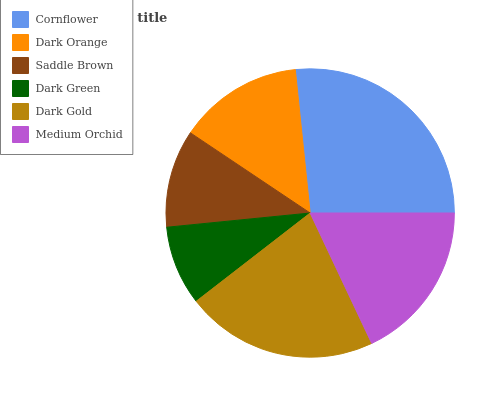Is Dark Green the minimum?
Answer yes or no. Yes. Is Cornflower the maximum?
Answer yes or no. Yes. Is Dark Orange the minimum?
Answer yes or no. No. Is Dark Orange the maximum?
Answer yes or no. No. Is Cornflower greater than Dark Orange?
Answer yes or no. Yes. Is Dark Orange less than Cornflower?
Answer yes or no. Yes. Is Dark Orange greater than Cornflower?
Answer yes or no. No. Is Cornflower less than Dark Orange?
Answer yes or no. No. Is Medium Orchid the high median?
Answer yes or no. Yes. Is Dark Orange the low median?
Answer yes or no. Yes. Is Dark Green the high median?
Answer yes or no. No. Is Dark Green the low median?
Answer yes or no. No. 